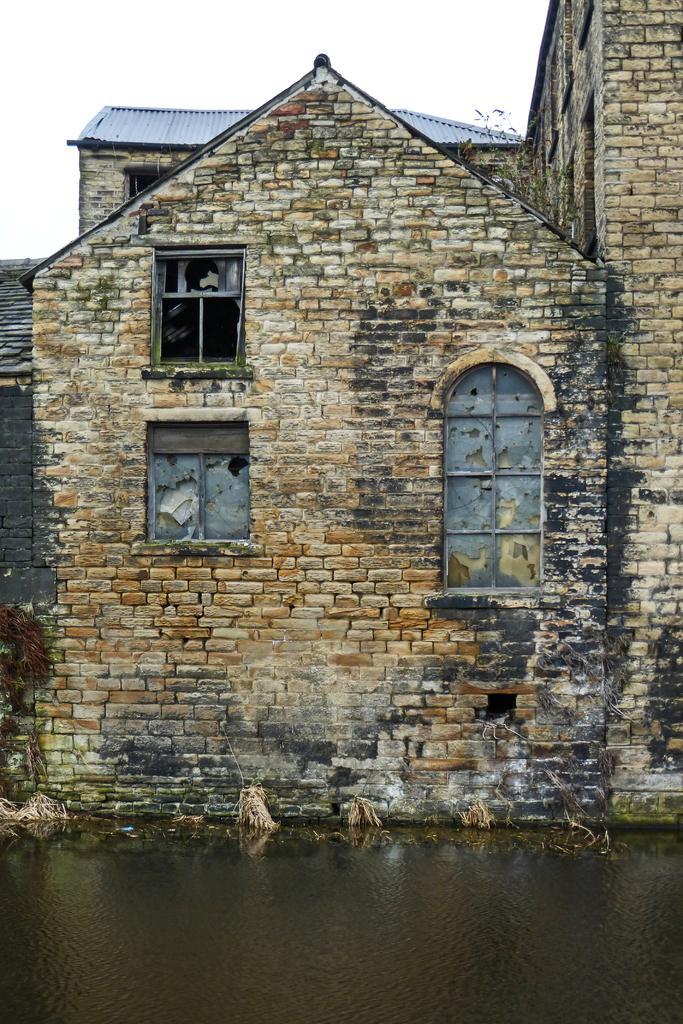In one or two sentences, can you explain what this image depicts? In the image in the center, we can see the sky, clouds, water, windows, roof and the brick wall. 